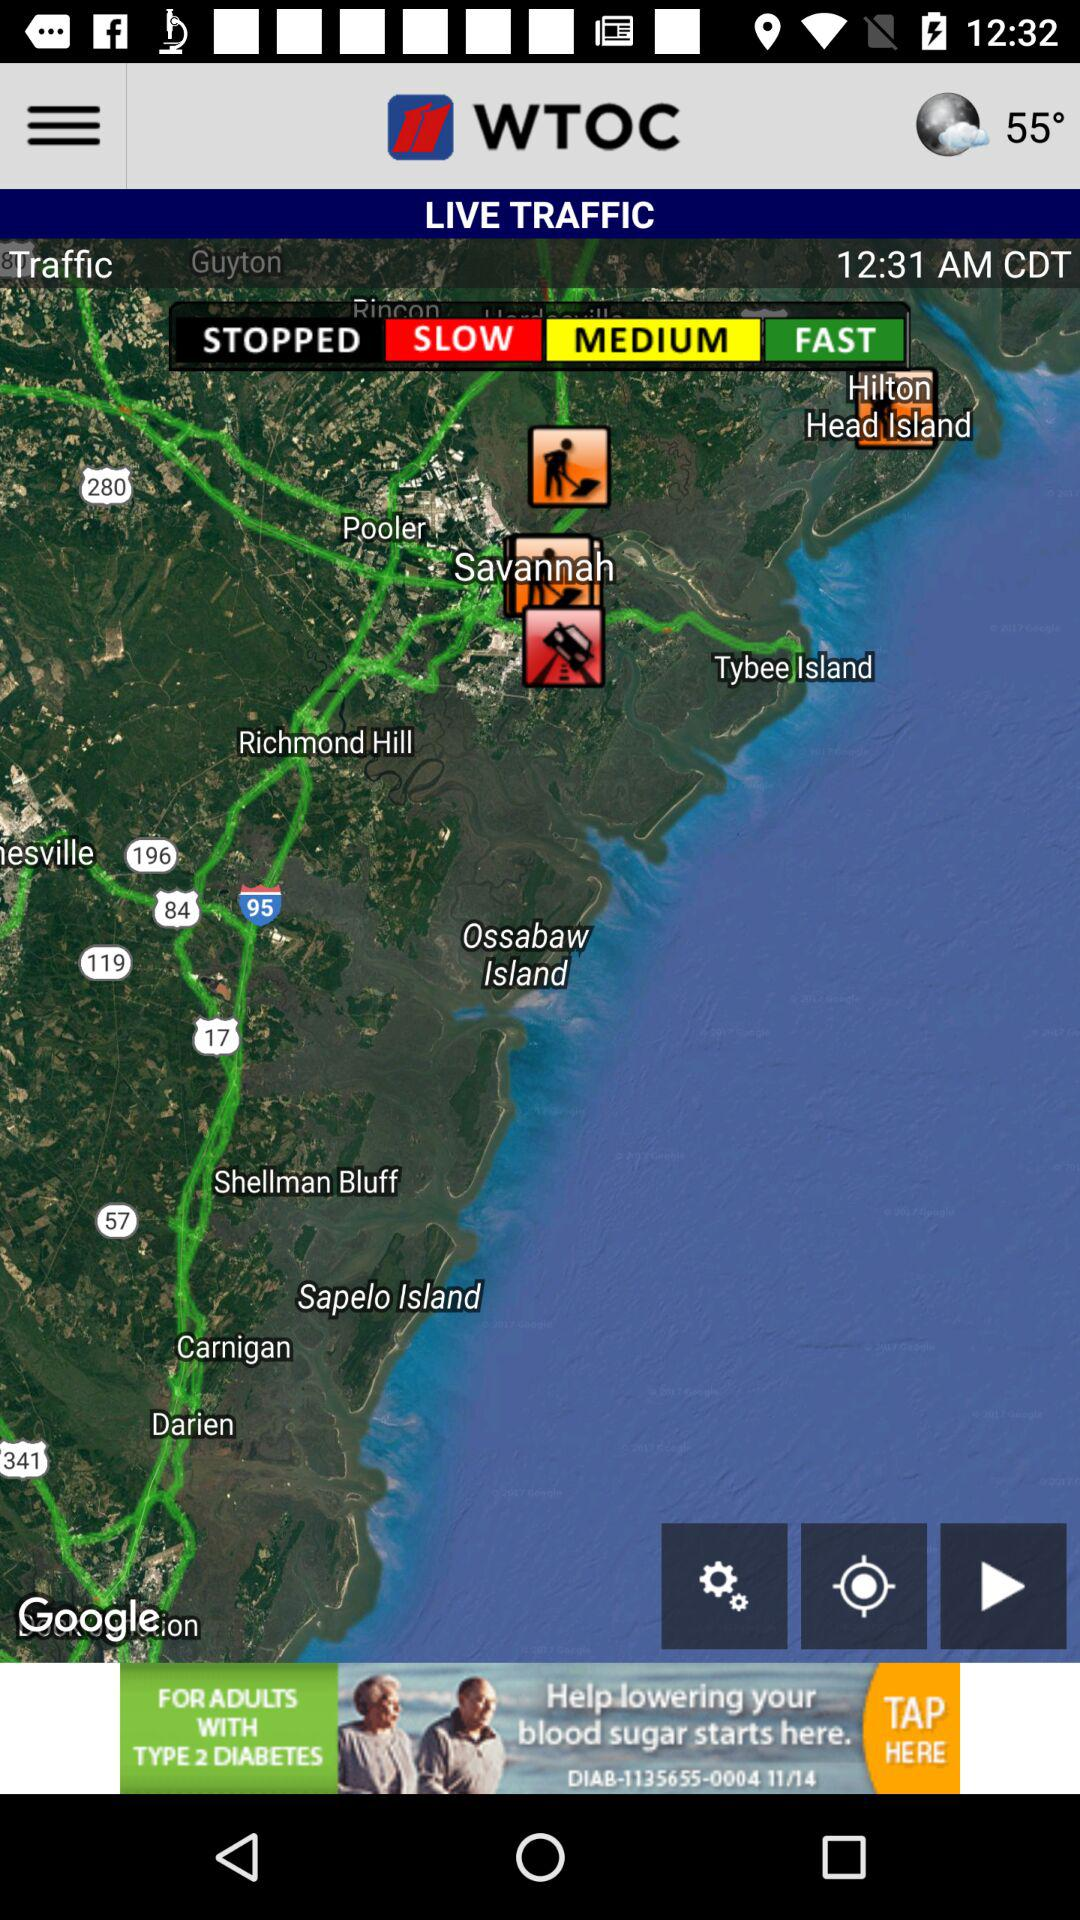What is the mentioned time? The mentioned time is 12:31 a.m. in Central Daylight Time. 